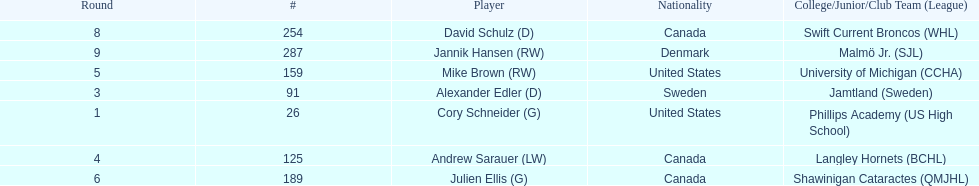Could you parse the entire table? {'header': ['Round', '#', 'Player', 'Nationality', 'College/Junior/Club Team (League)'], 'rows': [['8', '254', 'David Schulz (D)', 'Canada', 'Swift Current Broncos (WHL)'], ['9', '287', 'Jannik Hansen (RW)', 'Denmark', 'Malmö Jr. (SJL)'], ['5', '159', 'Mike Brown (RW)', 'United States', 'University of Michigan (CCHA)'], ['3', '91', 'Alexander Edler (D)', 'Sweden', 'Jamtland (Sweden)'], ['1', '26', 'Cory Schneider (G)', 'United States', 'Phillips Academy (US High School)'], ['4', '125', 'Andrew Sarauer (LW)', 'Canada', 'Langley Hornets (BCHL)'], ['6', '189', 'Julien Ellis (G)', 'Canada', 'Shawinigan Cataractes (QMJHL)']]} What is the name of the last player on this chart? Jannik Hansen (RW). 